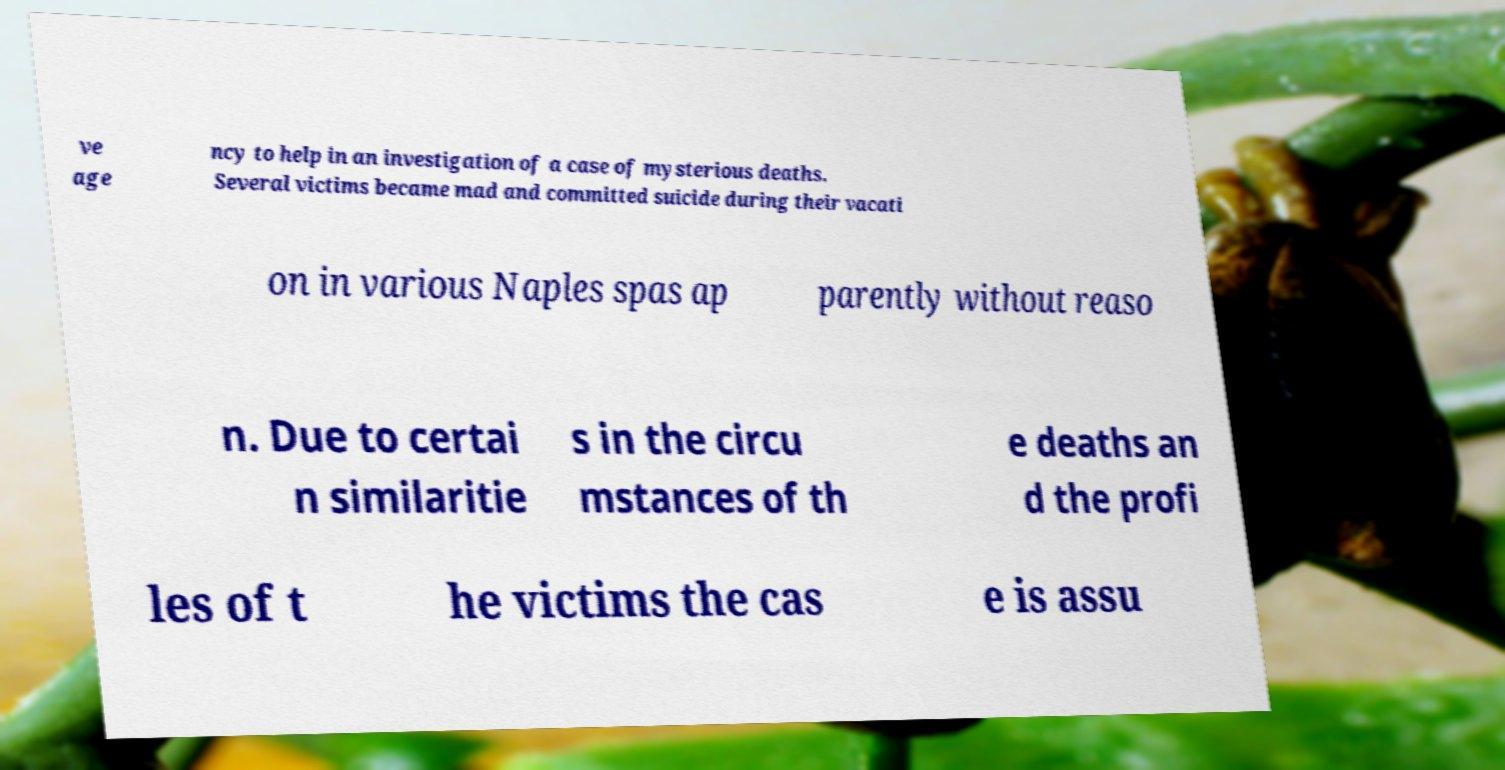Please read and relay the text visible in this image. What does it say? ve age ncy to help in an investigation of a case of mysterious deaths. Several victims became mad and committed suicide during their vacati on in various Naples spas ap parently without reaso n. Due to certai n similaritie s in the circu mstances of th e deaths an d the profi les of t he victims the cas e is assu 